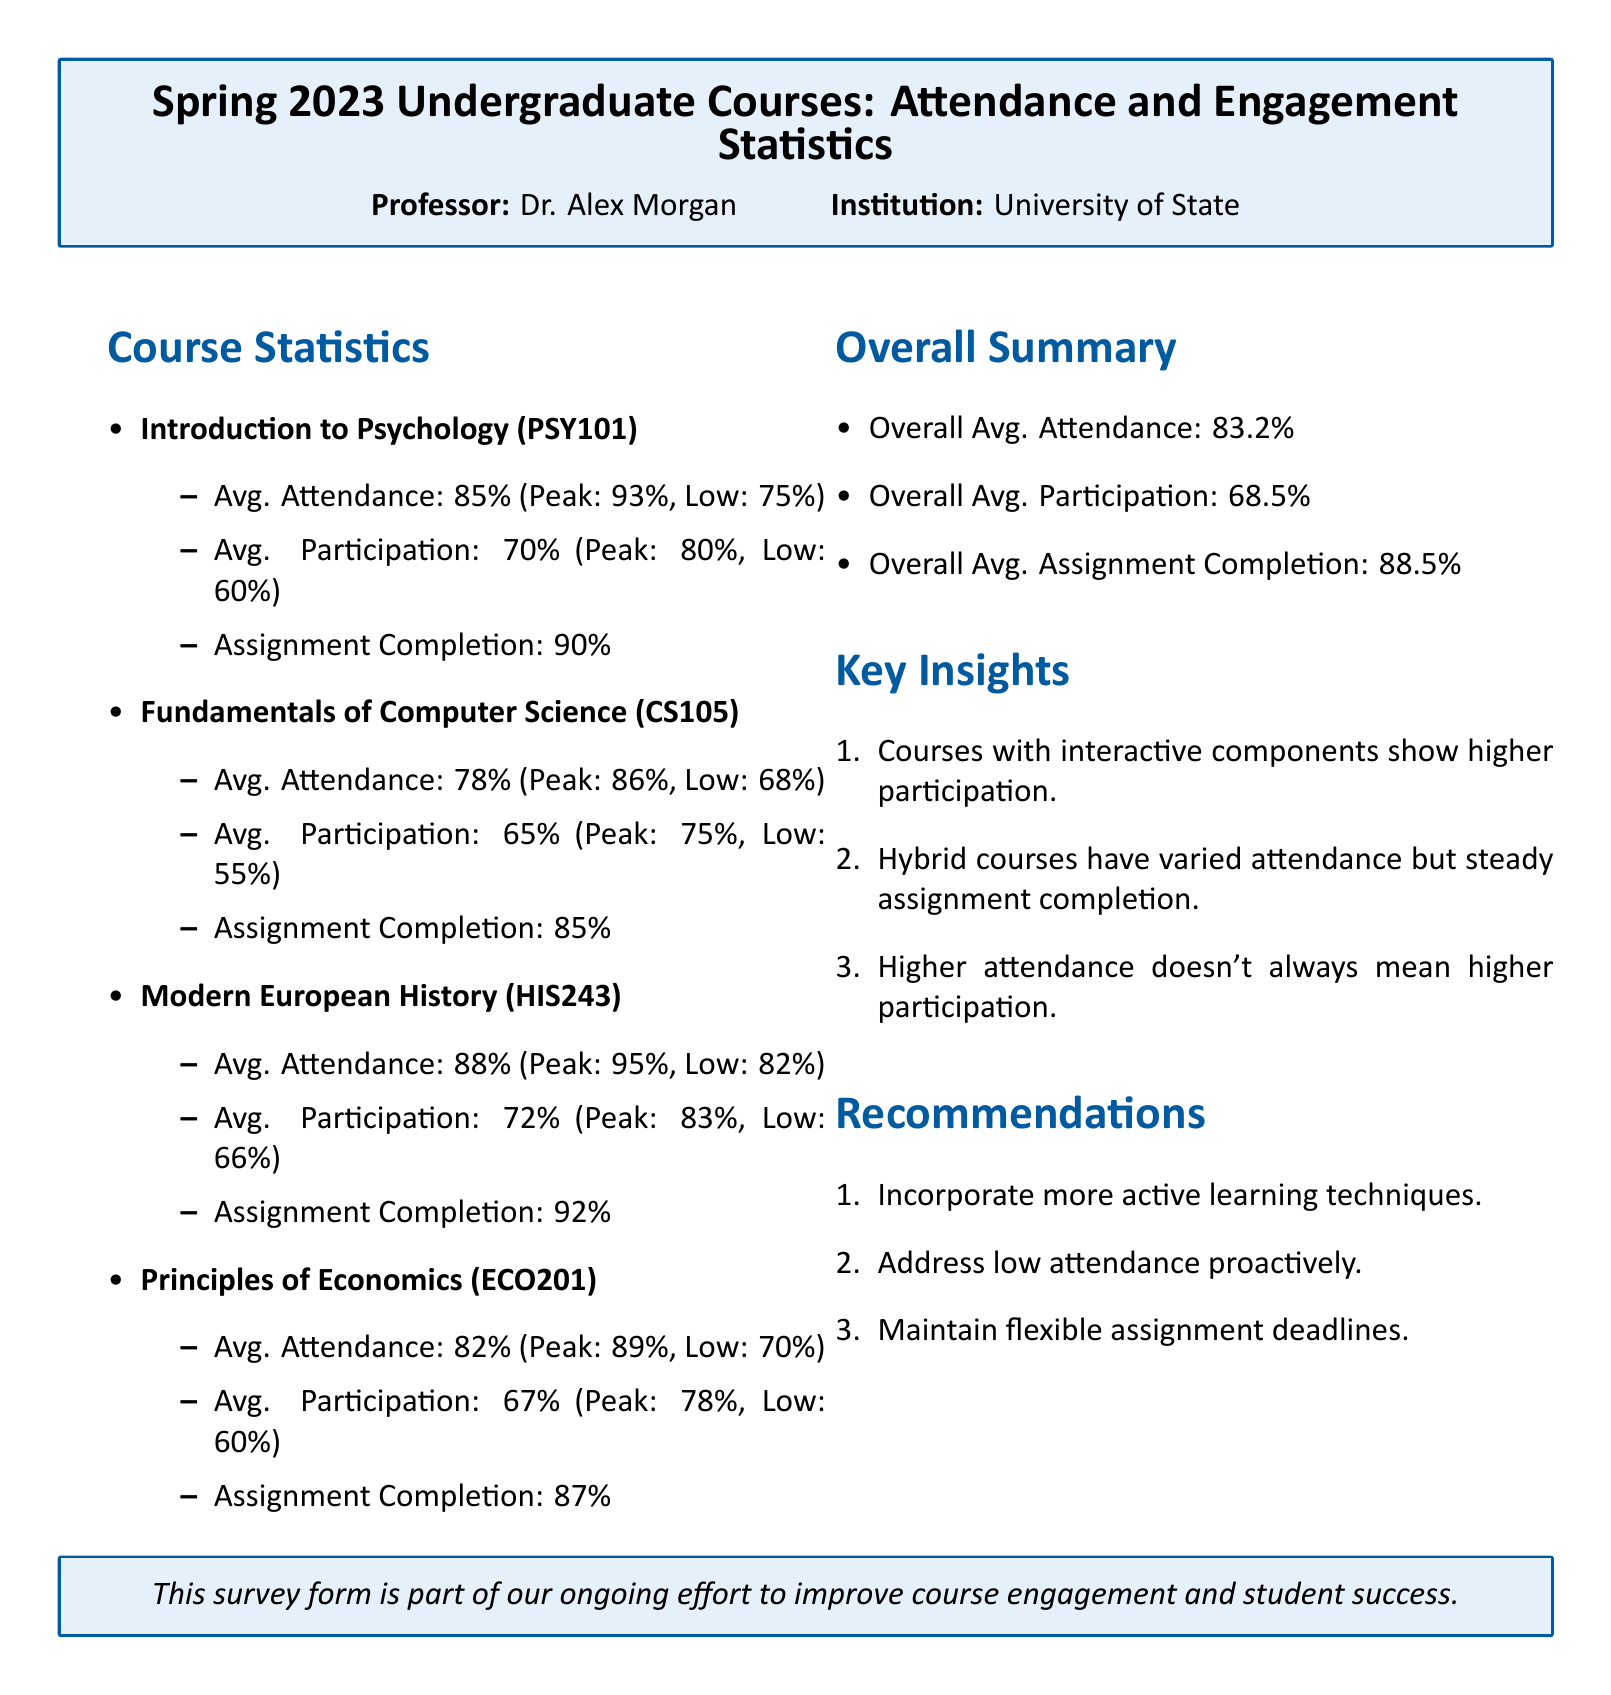What is the average attendance for Introduction to Psychology? The average attendance is specified under the course statistics for Introduction to Psychology, which is 85%.
Answer: 85% What is the peak participation percentage for Fundamentals of Computer Science? The peak participation percentage is found in the statistics for Fundamentals of Computer Science, which is 75%.
Answer: 75% Which course has the highest average attendance? The course with the highest average attendance is mentioned in the document as Modern European History with 88%.
Answer: Modern European History What is the overall average assignment completion percentage? The overall average assignment completion is outlined in the overall summary section, which is 88.5%.
Answer: 88.5% What recommendation is given to address low attendance? The recommendations section provides suggestions, where one is to address low attendance proactively.
Answer: Address low attendance proactively Which course has the lowest average participation? The lowest average participation can be found in the course statistics for Fundamentals of Computer Science, which is 65%.
Answer: Fundamentals of Computer Science What percentage of assignment completion does Principles of Economics have? The assignment completion percentage for Principles of Economics is listed under course statistics, which is 87%.
Answer: 87% What insight suggests a relationship between course format and attendance? The key insights mention that hybrid courses have varied attendance, indicating a relationship between course format and attendance.
Answer: Hybrid courses have varied attendance What is the overall average participation across all courses? The overall average participation figure is presented in the overall summary section, which is 68.5%.
Answer: 68.5% 